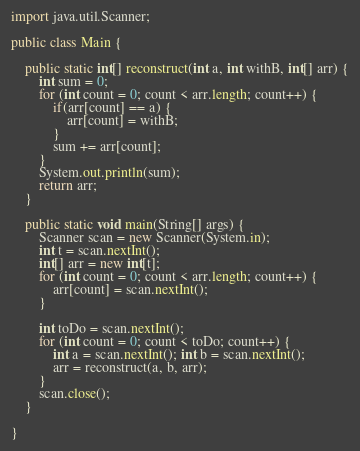Convert code to text. <code><loc_0><loc_0><loc_500><loc_500><_Java_>import java.util.Scanner;

public class Main {
	
	public static int[] reconstruct(int a, int withB, int[] arr) {
		int sum = 0;
		for (int count = 0; count < arr.length; count++) {
			if(arr[count] == a) {
				arr[count] = withB;
			}
			sum += arr[count];
		}
		System.out.println(sum);
		return arr;
	}

	public static void main(String[] args) {
		Scanner scan = new Scanner(System.in);
		int t = scan.nextInt();
		int[] arr = new int[t];
		for (int count = 0; count < arr.length; count++) {
			arr[count] = scan.nextInt();
		}
		
		int toDo = scan.nextInt();
		for (int count = 0; count < toDo; count++) {
			int a = scan.nextInt(); int b = scan.nextInt();
			arr = reconstruct(a, b, arr);
		}
		scan.close();
	}

}
</code> 